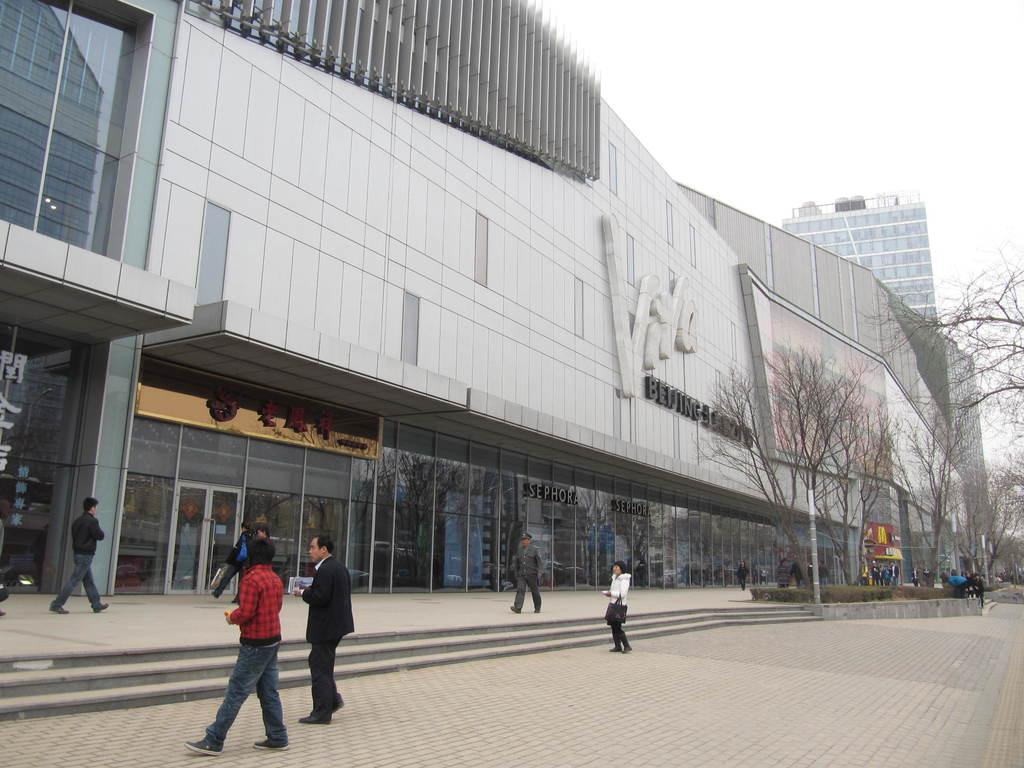What type of structures can be seen in the image? There are buildings in the image. What other natural elements are present in the image? There are trees in the image. Can you describe the people in the image? There are people in front of the building in the image. What architectural feature is visible in the image? There are stairs in the image. What can be seen in the background of the image? The sky is visible in the background of the image. What type of meal is being served in the picture? There is no meal present in the image; it features buildings, trees, people, stairs, and the sky. Can you describe the partner of the person in the image? There is no person or partner present in the image; it only shows buildings, trees, people, stairs, and the sky. 